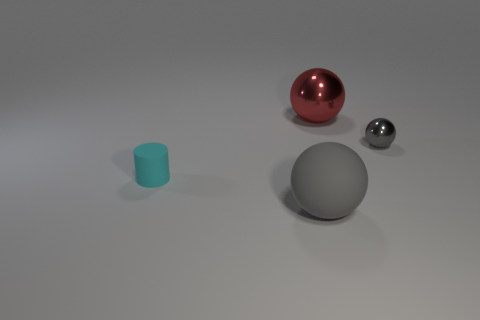Subtract all purple cylinders. How many gray spheres are left? 2 Subtract all gray shiny spheres. How many spheres are left? 2 Add 3 tiny cylinders. How many objects exist? 7 Subtract all spheres. How many objects are left? 1 Add 4 tiny spheres. How many tiny spheres exist? 5 Subtract 0 blue balls. How many objects are left? 4 Subtract all purple balls. Subtract all brown cubes. How many balls are left? 3 Subtract all large yellow blocks. Subtract all small cyan cylinders. How many objects are left? 3 Add 3 red metal balls. How many red metal balls are left? 4 